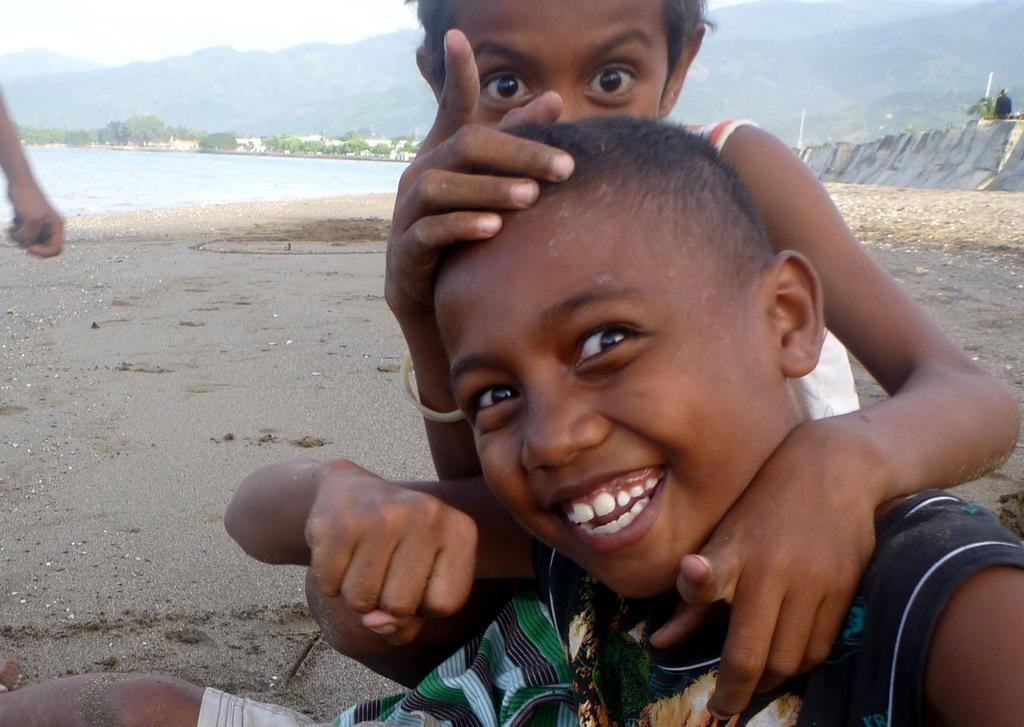How many children are in the image? There are two children in the image. Where are the children sitting? The children are sitting on the sand. What can be seen in the background of the image? There is water, a wall, hills, trees, and the sky visible in the background. What type of wine is the frog wearing in the image? There is no frog or wine present in the image. 